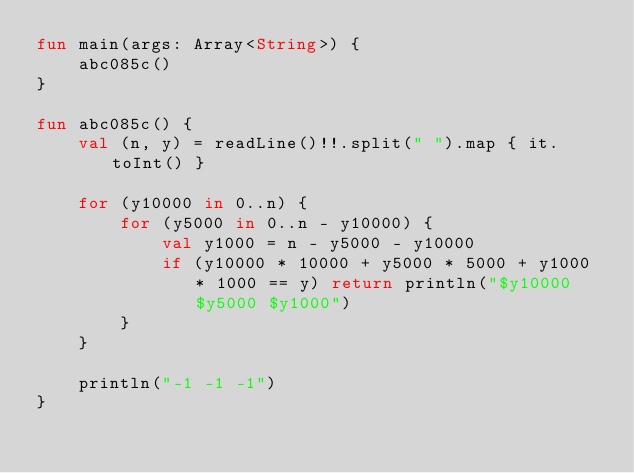<code> <loc_0><loc_0><loc_500><loc_500><_Kotlin_>fun main(args: Array<String>) {
    abc085c()
}

fun abc085c() {
    val (n, y) = readLine()!!.split(" ").map { it.toInt() }

    for (y10000 in 0..n) {
        for (y5000 in 0..n - y10000) {
            val y1000 = n - y5000 - y10000
            if (y10000 * 10000 + y5000 * 5000 + y1000 * 1000 == y) return println("$y10000 $y5000 $y1000")
        }
    }

    println("-1 -1 -1")
}
</code> 